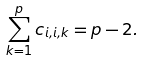<formula> <loc_0><loc_0><loc_500><loc_500>\sum _ { k = 1 } ^ { p } c _ { i , i , k } = p - 2 .</formula> 